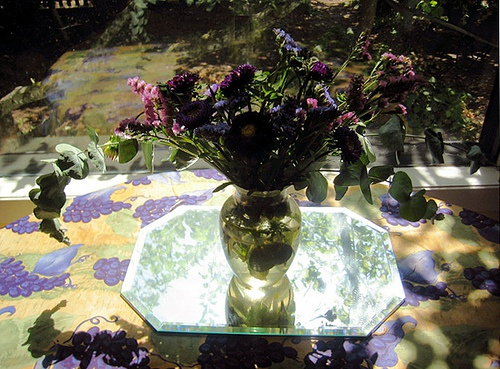Describe the objects in this image and their specific colors. I can see bowl in black, ivory, darkgray, and beige tones and vase in black, darkgreen, olive, and darkgray tones in this image. 